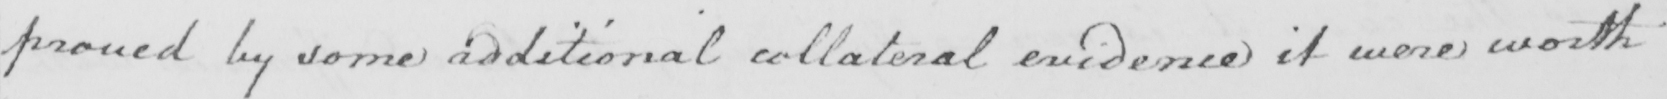Please provide the text content of this handwritten line. proved by some additional collateral evidence it were worth 